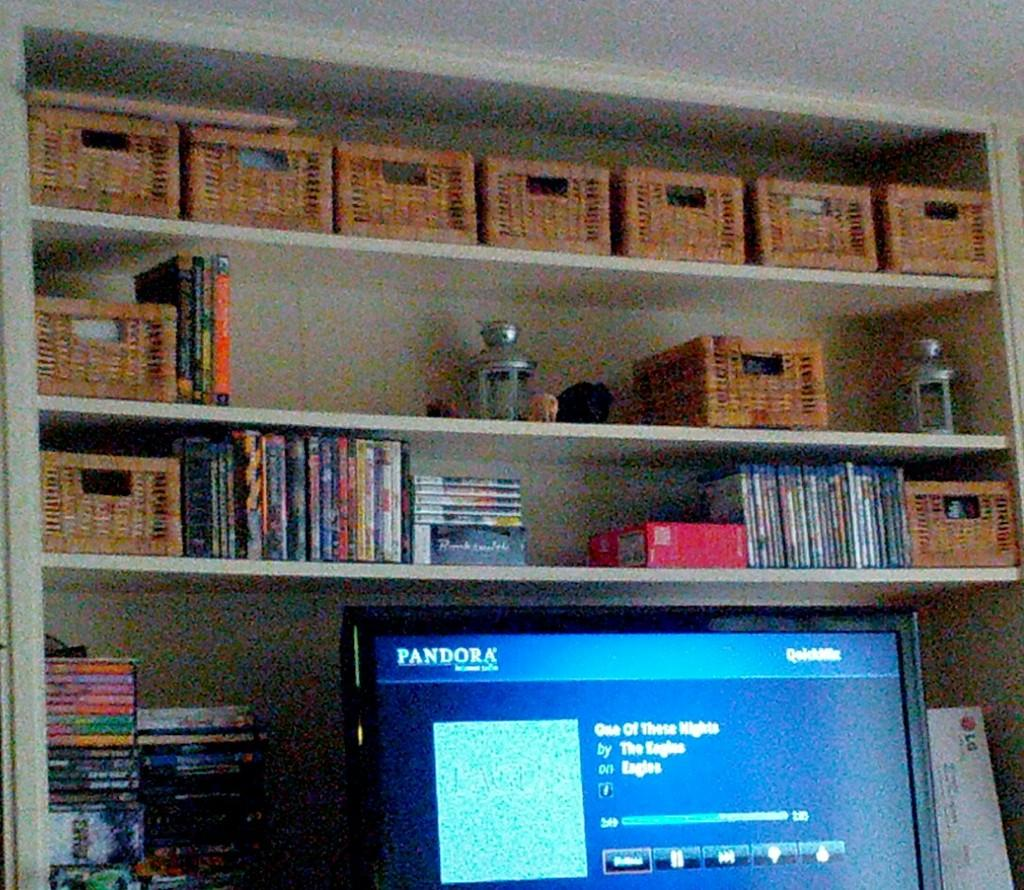What is the main object in the foreground of the image? There is a television in the foreground of the image. What can be seen in the background of the image? There is a group of books and baskets placed on racks in the background of the image. Can you see the view from the window in the image? There is no window or view visible in the image; it only features a television, books, and baskets placed on racks. 